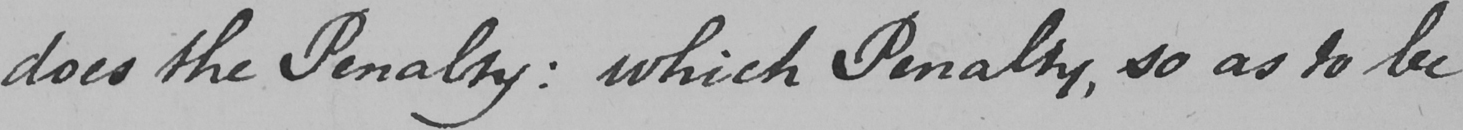Please transcribe the handwritten text in this image. does the Penalty :  which Penalty , so as to be 